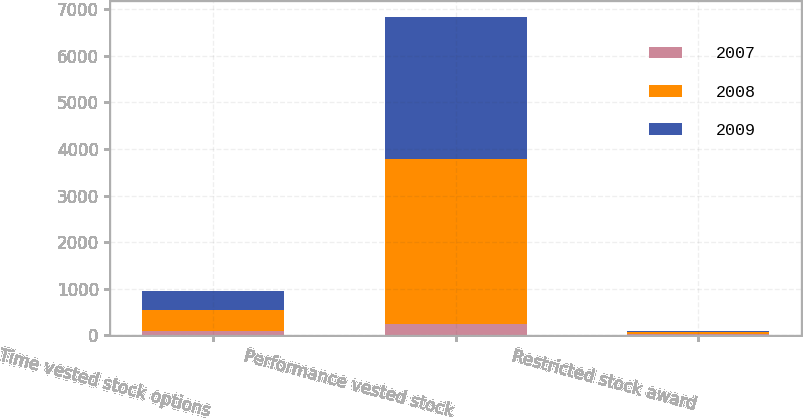Convert chart. <chart><loc_0><loc_0><loc_500><loc_500><stacked_bar_chart><ecel><fcel>Time vested stock options<fcel>Performance vested stock<fcel>Restricted stock award<nl><fcel>2007<fcel>87<fcel>247.5<fcel>31<nl><fcel>2008<fcel>464<fcel>3538<fcel>33<nl><fcel>2009<fcel>408<fcel>3047<fcel>32<nl></chart> 